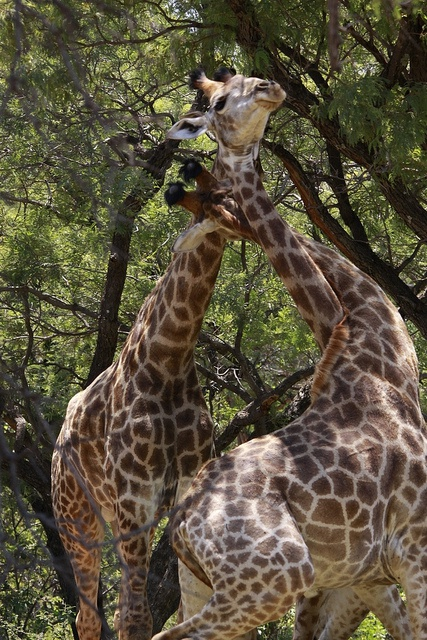Describe the objects in this image and their specific colors. I can see giraffe in khaki, gray, black, and maroon tones and giraffe in khaki, black, maroon, and gray tones in this image. 